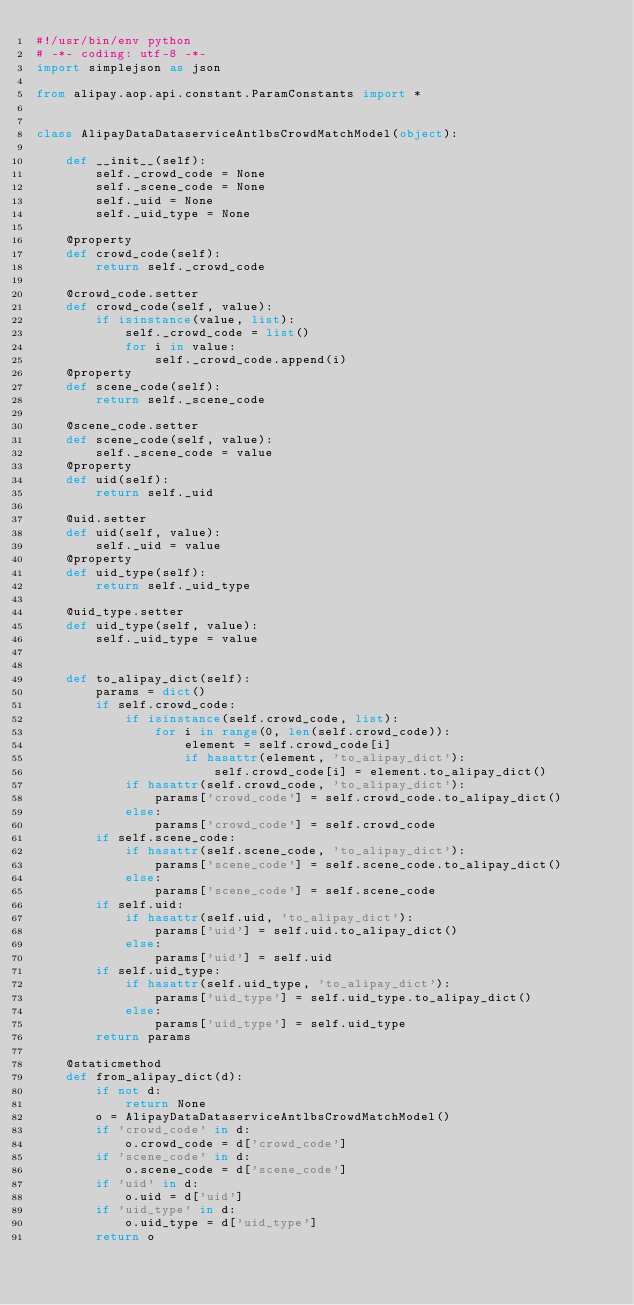<code> <loc_0><loc_0><loc_500><loc_500><_Python_>#!/usr/bin/env python
# -*- coding: utf-8 -*-
import simplejson as json

from alipay.aop.api.constant.ParamConstants import *


class AlipayDataDataserviceAntlbsCrowdMatchModel(object):

    def __init__(self):
        self._crowd_code = None
        self._scene_code = None
        self._uid = None
        self._uid_type = None

    @property
    def crowd_code(self):
        return self._crowd_code

    @crowd_code.setter
    def crowd_code(self, value):
        if isinstance(value, list):
            self._crowd_code = list()
            for i in value:
                self._crowd_code.append(i)
    @property
    def scene_code(self):
        return self._scene_code

    @scene_code.setter
    def scene_code(self, value):
        self._scene_code = value
    @property
    def uid(self):
        return self._uid

    @uid.setter
    def uid(self, value):
        self._uid = value
    @property
    def uid_type(self):
        return self._uid_type

    @uid_type.setter
    def uid_type(self, value):
        self._uid_type = value


    def to_alipay_dict(self):
        params = dict()
        if self.crowd_code:
            if isinstance(self.crowd_code, list):
                for i in range(0, len(self.crowd_code)):
                    element = self.crowd_code[i]
                    if hasattr(element, 'to_alipay_dict'):
                        self.crowd_code[i] = element.to_alipay_dict()
            if hasattr(self.crowd_code, 'to_alipay_dict'):
                params['crowd_code'] = self.crowd_code.to_alipay_dict()
            else:
                params['crowd_code'] = self.crowd_code
        if self.scene_code:
            if hasattr(self.scene_code, 'to_alipay_dict'):
                params['scene_code'] = self.scene_code.to_alipay_dict()
            else:
                params['scene_code'] = self.scene_code
        if self.uid:
            if hasattr(self.uid, 'to_alipay_dict'):
                params['uid'] = self.uid.to_alipay_dict()
            else:
                params['uid'] = self.uid
        if self.uid_type:
            if hasattr(self.uid_type, 'to_alipay_dict'):
                params['uid_type'] = self.uid_type.to_alipay_dict()
            else:
                params['uid_type'] = self.uid_type
        return params

    @staticmethod
    def from_alipay_dict(d):
        if not d:
            return None
        o = AlipayDataDataserviceAntlbsCrowdMatchModel()
        if 'crowd_code' in d:
            o.crowd_code = d['crowd_code']
        if 'scene_code' in d:
            o.scene_code = d['scene_code']
        if 'uid' in d:
            o.uid = d['uid']
        if 'uid_type' in d:
            o.uid_type = d['uid_type']
        return o


</code> 